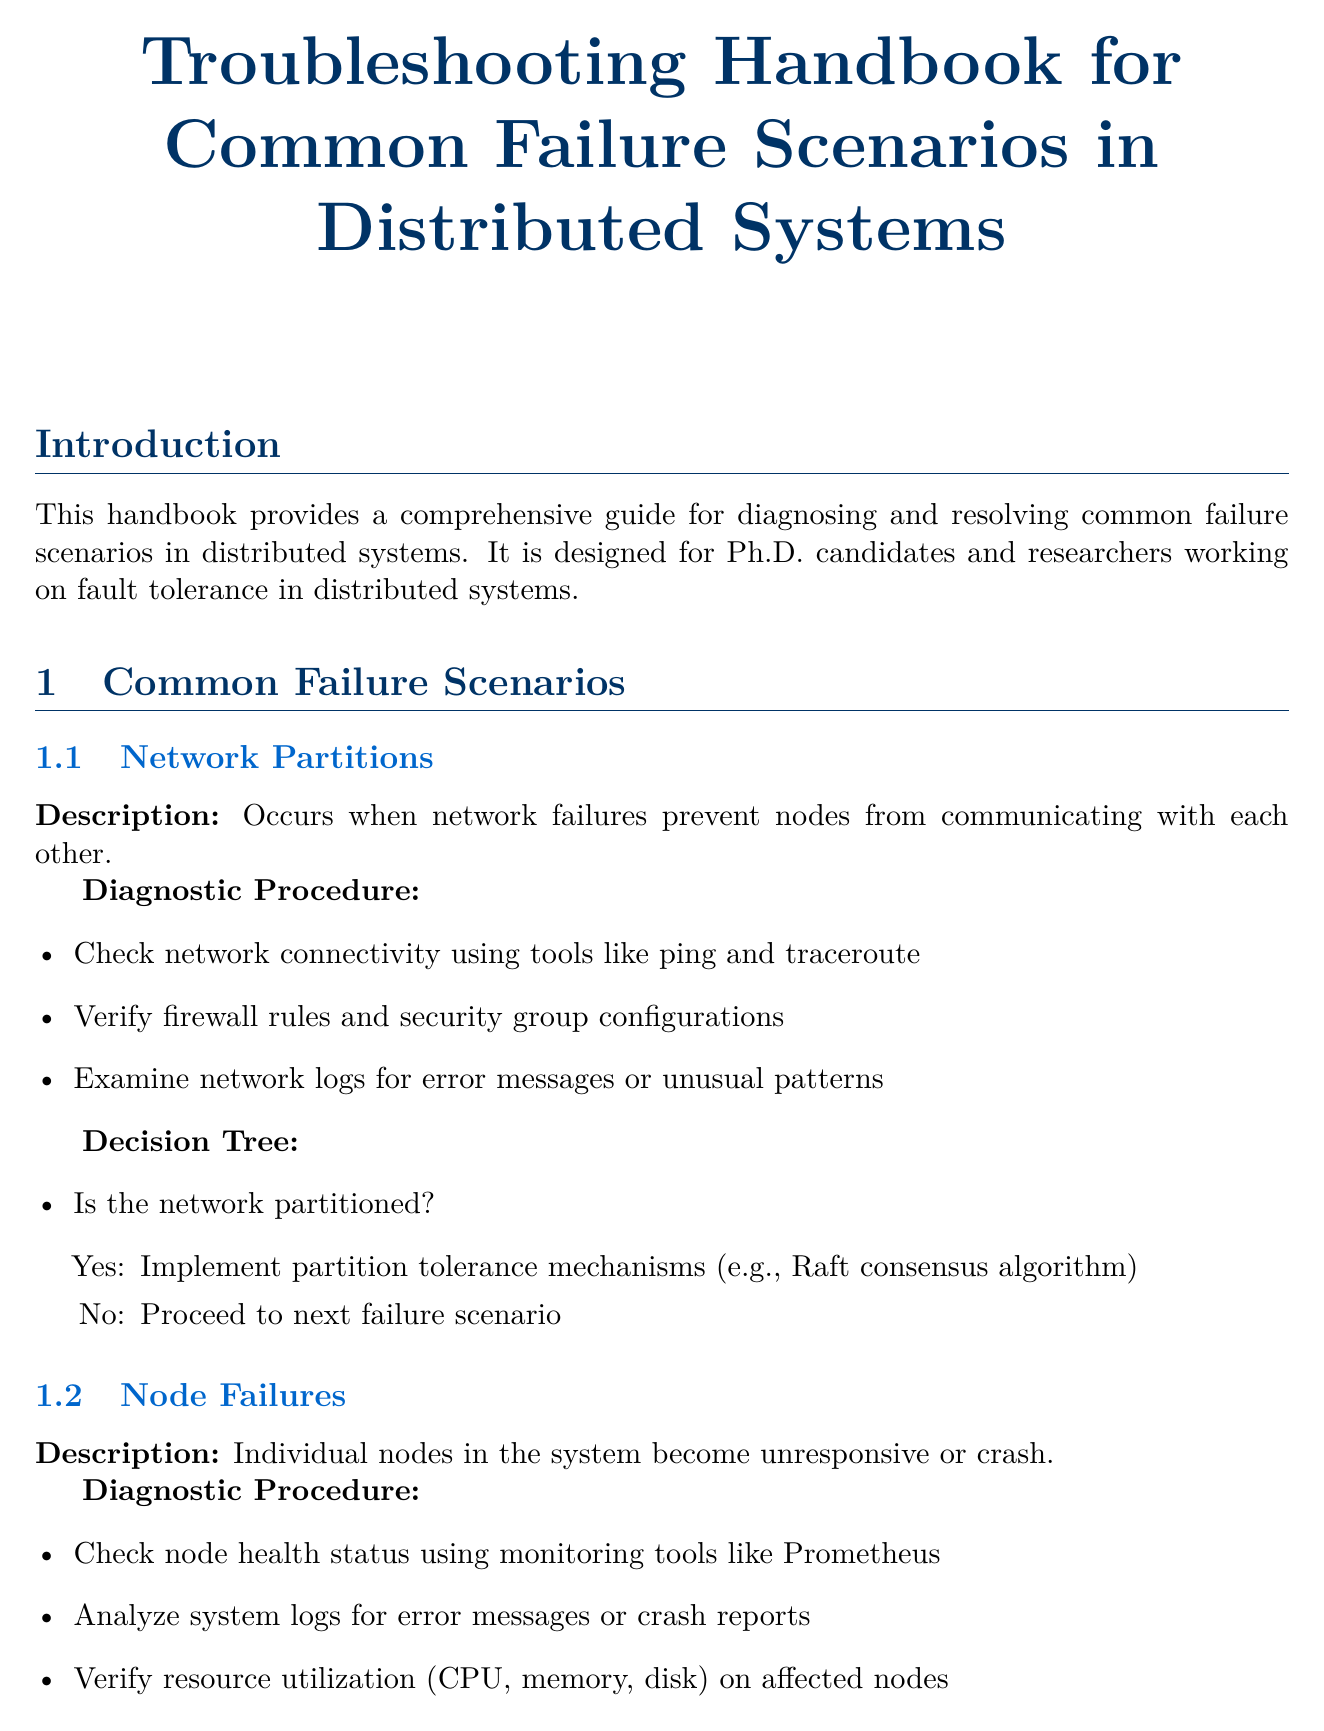What is the title of the handbook? The title of the handbook is specified at the start of the document.
Answer: Troubleshooting Handbook for Common Failure Scenarios in Distributed Systems How many common failure scenarios are there? The document lists three common failure scenarios under the common failure scenarios section.
Answer: Three What is the decision tree's root for data inconsistency? The decision tree's root for data inconsistency is stated as the first question in its specific section.
Answer: Is the inconsistency due to network delays? What tool is suggested for checking node health status? The document recommends a specific monitoring tool for checking node health in the diagnostic procedure for node failures.
Answer: Prometheus What key concept is associated with Google Spanner? Key points are mentioned for each case study, and one specific technology is highlighted in relation to Google Spanner.
Answer: TrueTime API What advanced diagnostic technique involves deliberate failure introduction? A specific advanced diagnostic technique is named that involves intentionally causing failures to test systems.
Answer: Chaos Engineering What are the three research directions highlighted in the handbook? The document lists topics under research directions, giving a quick overview of future focus areas.
Answer: Self-healing systems, quantum-resistant consensus algorithms, edge computing fault tolerance Is the handbook intended for practitioners outside of academia? The intended audience of the handbook is mentioned in the introduction, indicating its primary group.
Answer: No 